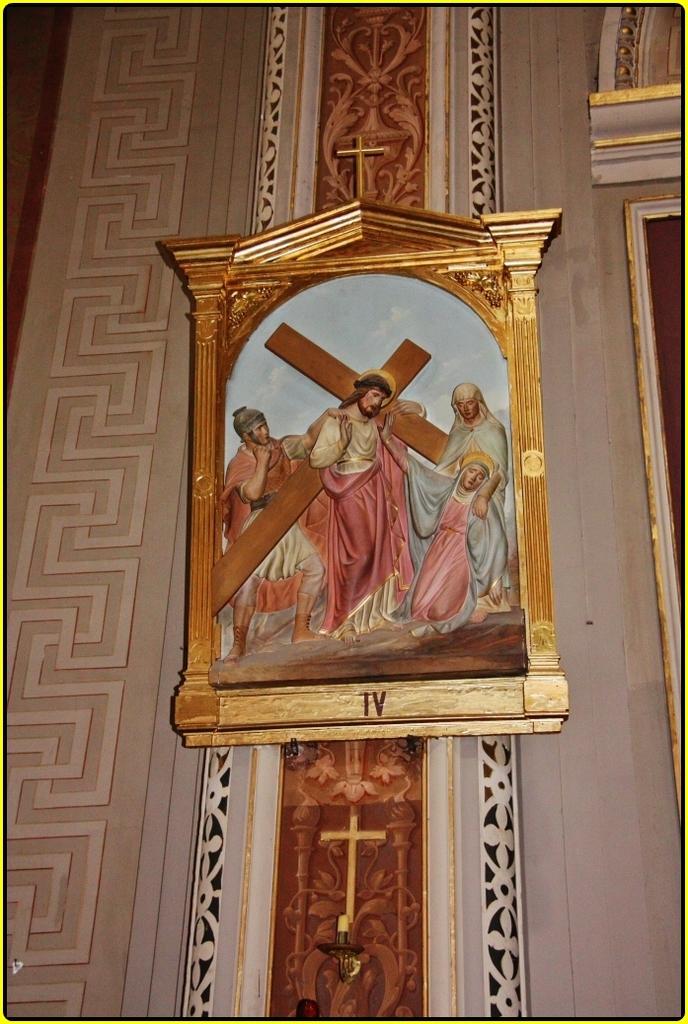What roman numeral is near the bottom of the painting?
Your answer should be compact. Iv. 